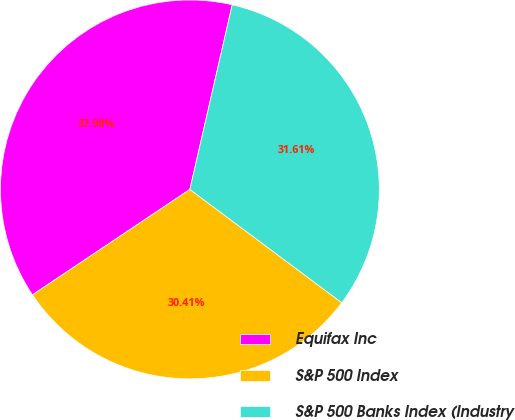<chart> <loc_0><loc_0><loc_500><loc_500><pie_chart><fcel>Equifax Inc<fcel>S&P 500 Index<fcel>S&P 500 Banks Index (Industry<nl><fcel>37.98%<fcel>30.41%<fcel>31.61%<nl></chart> 